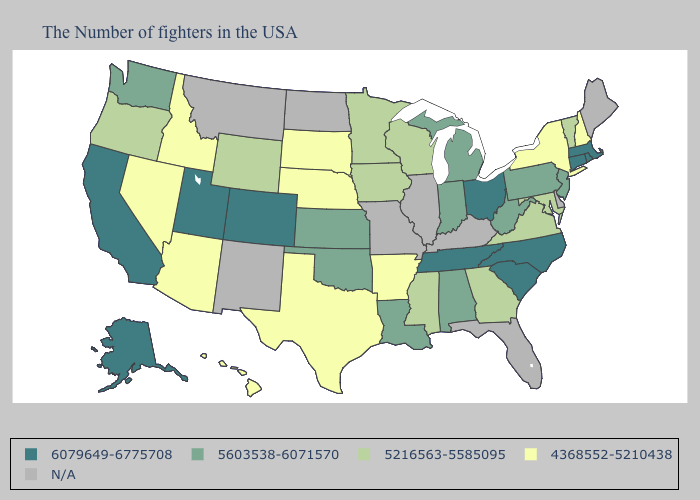Name the states that have a value in the range 5603538-6071570?
Keep it brief. New Jersey, Pennsylvania, West Virginia, Michigan, Indiana, Alabama, Louisiana, Kansas, Oklahoma, Washington. Among the states that border New Hampshire , does Vermont have the lowest value?
Concise answer only. Yes. Among the states that border Colorado , which have the lowest value?
Write a very short answer. Nebraska, Arizona. What is the value of Washington?
Quick response, please. 5603538-6071570. What is the value of Kansas?
Write a very short answer. 5603538-6071570. Does Connecticut have the lowest value in the USA?
Short answer required. No. Among the states that border Virginia , does Tennessee have the highest value?
Give a very brief answer. Yes. Does Arizona have the highest value in the West?
Give a very brief answer. No. What is the highest value in the South ?
Give a very brief answer. 6079649-6775708. Which states have the highest value in the USA?
Quick response, please. Massachusetts, Rhode Island, Connecticut, North Carolina, South Carolina, Ohio, Tennessee, Colorado, Utah, California, Alaska. Among the states that border Utah , does Colorado have the highest value?
Be succinct. Yes. What is the value of Kentucky?
Give a very brief answer. N/A. What is the highest value in states that border Arkansas?
Short answer required. 6079649-6775708. 